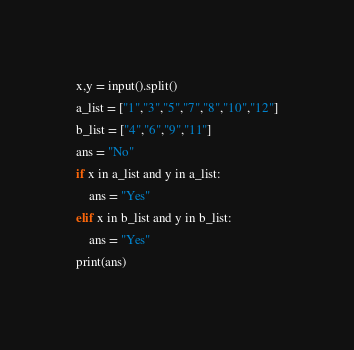Convert code to text. <code><loc_0><loc_0><loc_500><loc_500><_Python_>x,y = input().split()
a_list = ["1","3","5","7","8","10","12"]
b_list = ["4","6","9","11"]
ans = "No"
if x in a_list and y in a_list:
	ans = "Yes"
elif x in b_list and y in b_list:
	ans = "Yes"
print(ans)</code> 